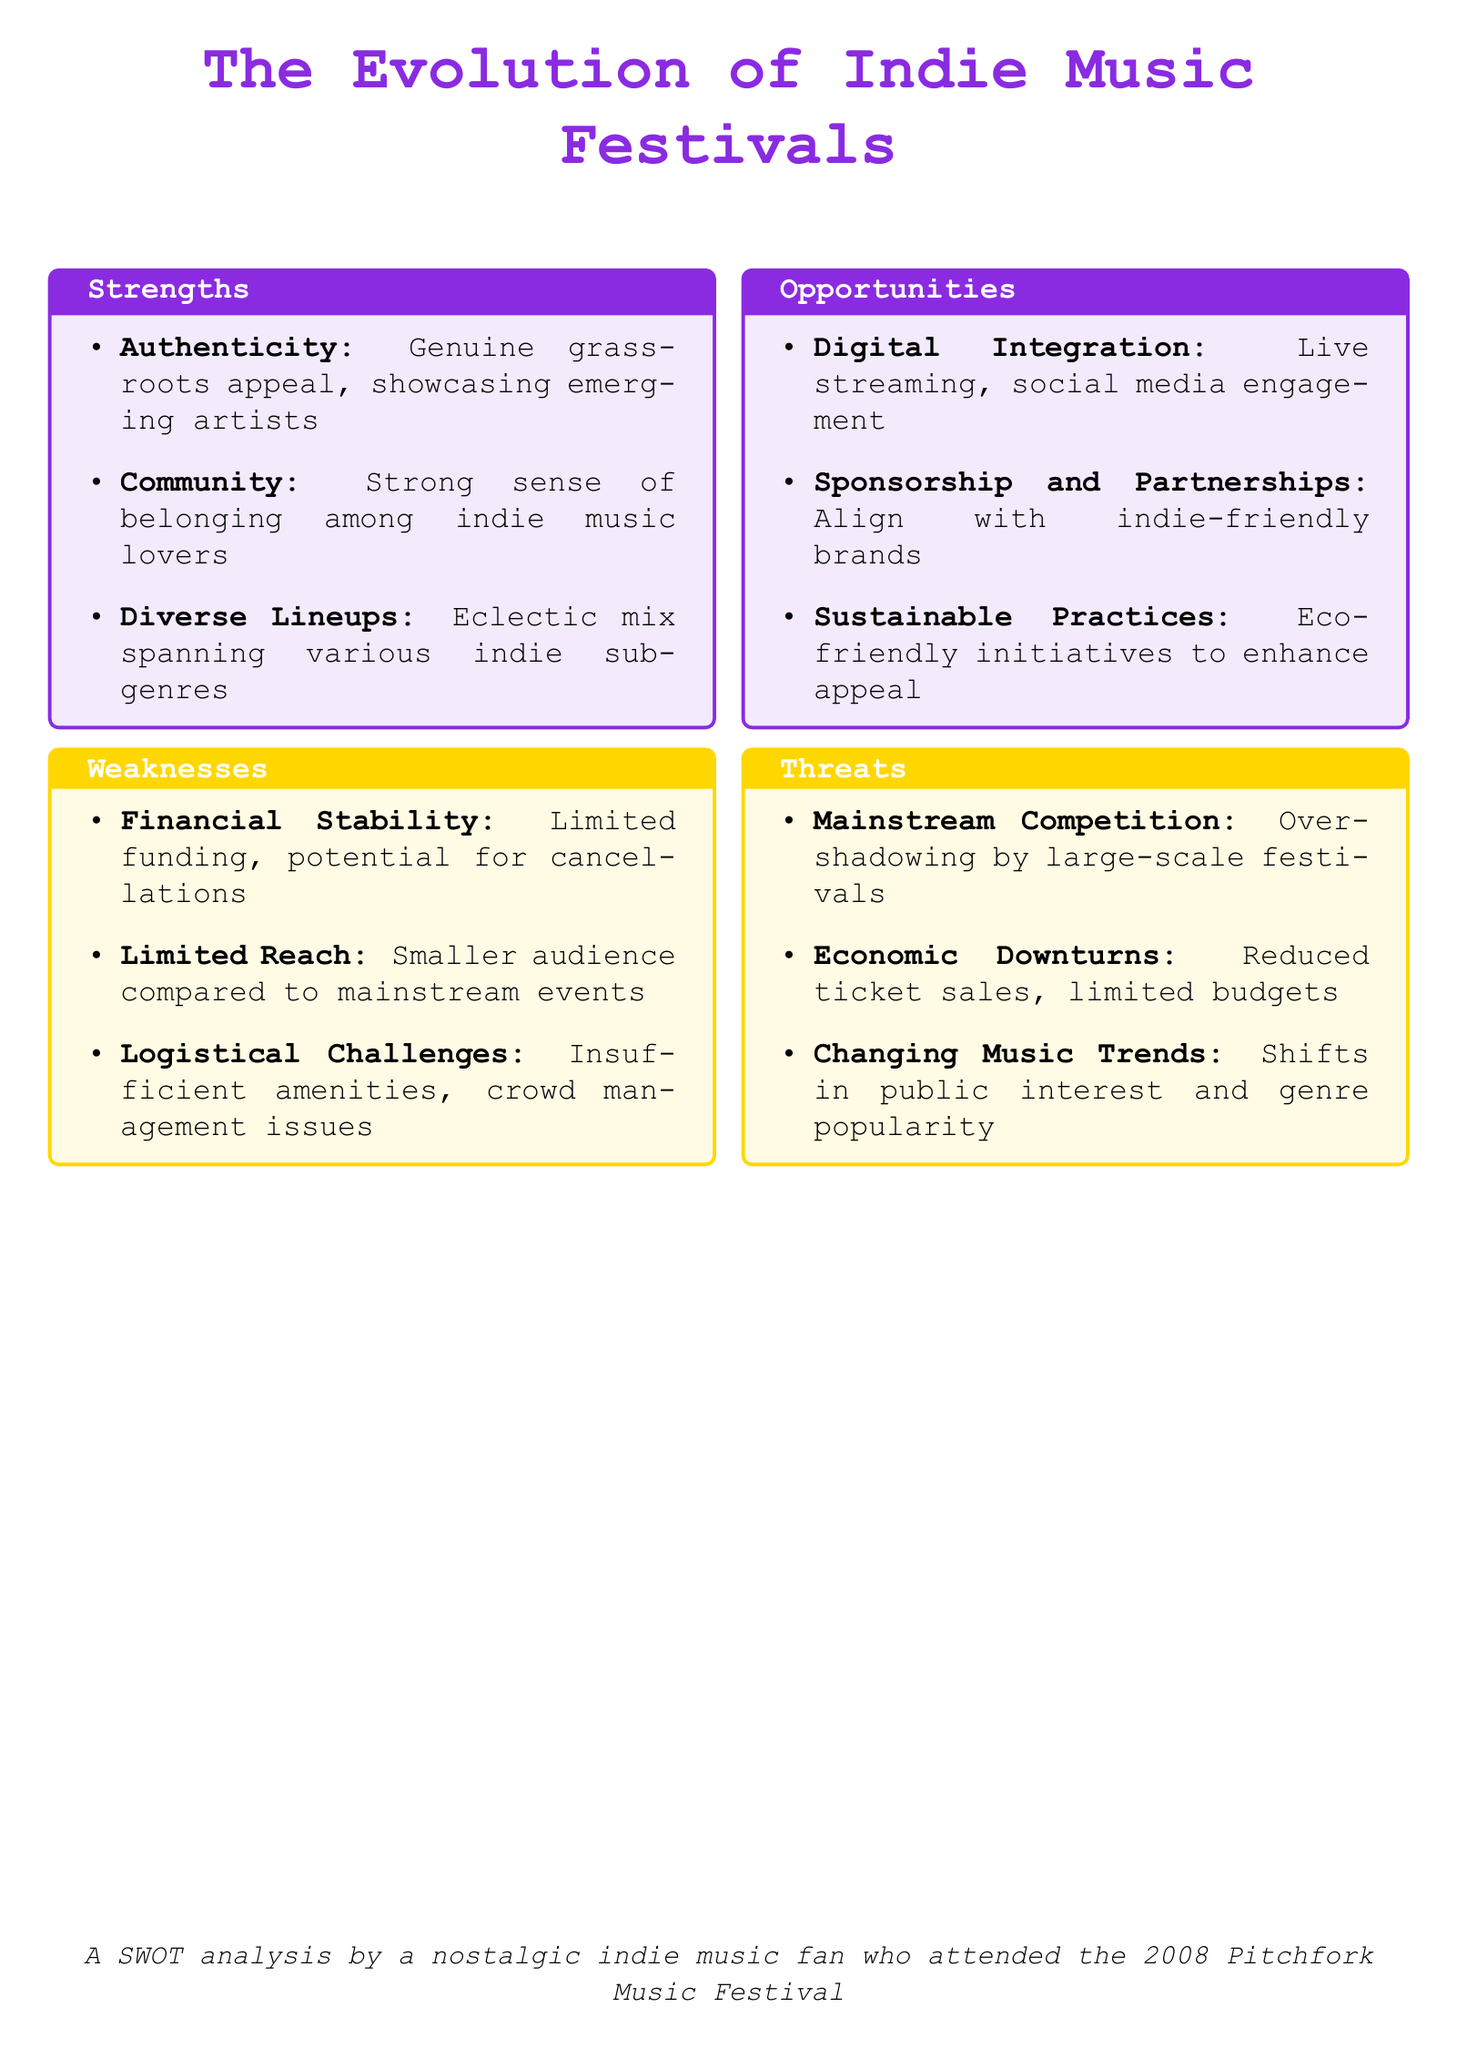what is a key strength of indie music festivals? The document mentions authenticity as a strength, highlighting the genuine grassroots appeal of these festivals.
Answer: Authenticity what is one identified weakness of indie music festivals? The document lists limited funding as a weakness, indicating potential for financial instability.
Answer: Financial Stability which opportunity involves technology? The document states that digital integration is an opportunity, particularly noting live streaming and social media engagement.
Answer: Digital Integration name one threat to indie music festivals. The document highlights mainstream competition as a significant threat to indie music festivals.
Answer: Mainstream Competition how many strengths are listed in the document? The document enumerates three specific strengths, making it clear there are multiple strengths outlined.
Answer: Three what is the color used for the strengths section? The document specifies that the strengths section employs the color corresponding to indie, indicated as indigo.
Answer: Indigo what type of practices is suggested as an opportunity in the festival context? The document suggests sustainable practices as an opportunity for indie music festivals to enhance their appeal.
Answer: Sustainable Practices what do indie music festivals provide to music lovers? The document emphasizes that indie music festivals offer a strong sense of community and belonging among music fans.
Answer: Community which festival is mentioned in the document's attribution? The document attributes the analysis to a nostalgic indie music fan who attended the Pitchfork Music Festival.
Answer: Pitchfork Music Festival 